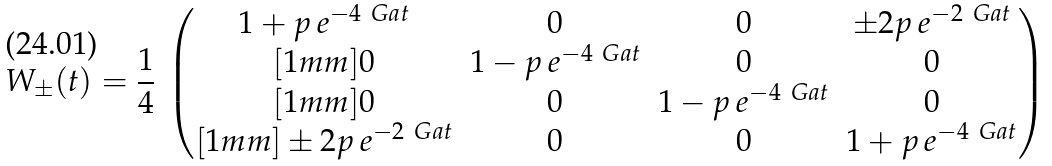<formula> <loc_0><loc_0><loc_500><loc_500>W _ { \pm } ( t ) = \frac { 1 } { 4 } \, \begin{pmatrix} 1 + p \, e ^ { - 4 \ G a t } & 0 & 0 & \pm 2 p \, e ^ { - 2 \ G a t } \\ [ 1 m m ] 0 & 1 - p \, e ^ { - 4 \ G a t } & 0 & 0 \\ [ 1 m m ] 0 & 0 & 1 - p \, e ^ { - 4 \ G a t } & 0 \\ [ 1 m m ] \pm 2 p \, e ^ { - 2 \ G a t } & 0 & 0 & 1 + p \, e ^ { - 4 \ G a t } \end{pmatrix}</formula> 